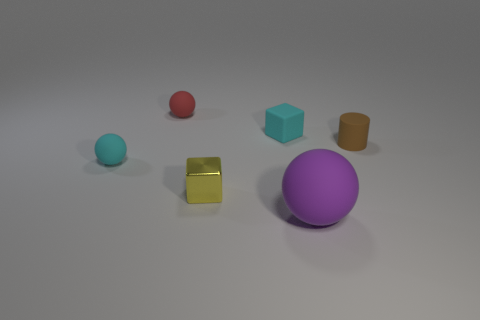Does the cube that is behind the yellow object have the same size as the red ball?
Provide a succinct answer. Yes. Is the number of objects on the left side of the red rubber sphere the same as the number of small green blocks?
Your answer should be compact. No. How many things are matte balls that are in front of the small metal block or metallic cubes?
Offer a terse response. 2. What shape is the rubber object that is both behind the purple ball and in front of the small rubber cylinder?
Make the answer very short. Sphere. What number of objects are either things on the right side of the cyan rubber block or small metallic blocks that are behind the large rubber ball?
Your answer should be compact. 3. How many other objects are there of the same size as the cylinder?
Offer a terse response. 4. There is a matte ball that is on the right side of the metallic thing; does it have the same color as the rubber cylinder?
Provide a succinct answer. No. What size is the matte thing that is both on the right side of the metallic cube and on the left side of the large rubber object?
Your response must be concise. Small. What number of big objects are either brown cylinders or red matte balls?
Ensure brevity in your answer.  0. There is a small cyan object that is behind the brown object; what is its shape?
Your answer should be very brief. Cube. 